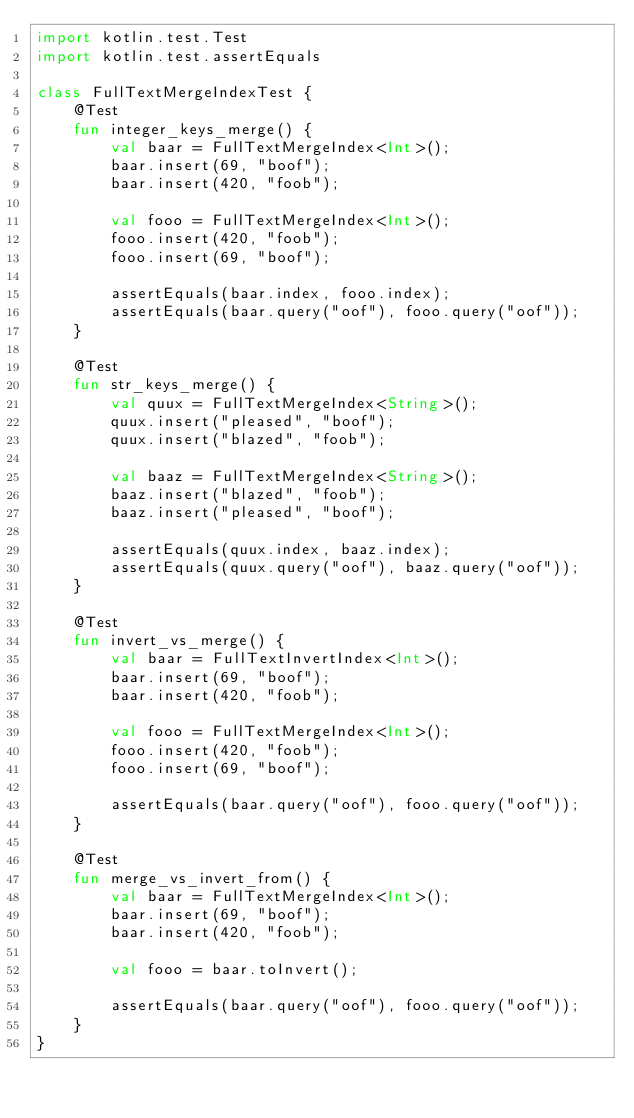Convert code to text. <code><loc_0><loc_0><loc_500><loc_500><_Kotlin_>import kotlin.test.Test
import kotlin.test.assertEquals

class FullTextMergeIndexTest {
    @Test
    fun integer_keys_merge() {
        val baar = FullTextMergeIndex<Int>();
        baar.insert(69, "boof");
        baar.insert(420, "foob");

        val fooo = FullTextMergeIndex<Int>();
        fooo.insert(420, "foob");
        fooo.insert(69, "boof");

        assertEquals(baar.index, fooo.index);
        assertEquals(baar.query("oof"), fooo.query("oof"));
    }

    @Test
    fun str_keys_merge() {
        val quux = FullTextMergeIndex<String>();
        quux.insert("pleased", "boof");
        quux.insert("blazed", "foob");

        val baaz = FullTextMergeIndex<String>();
        baaz.insert("blazed", "foob");
        baaz.insert("pleased", "boof");

        assertEquals(quux.index, baaz.index);
        assertEquals(quux.query("oof"), baaz.query("oof"));
    }

    @Test
    fun invert_vs_merge() {
        val baar = FullTextInvertIndex<Int>();
        baar.insert(69, "boof");
        baar.insert(420, "foob");

        val fooo = FullTextMergeIndex<Int>();
        fooo.insert(420, "foob");
        fooo.insert(69, "boof");

        assertEquals(baar.query("oof"), fooo.query("oof"));
    }

    @Test
    fun merge_vs_invert_from() {
        val baar = FullTextMergeIndex<Int>();
        baar.insert(69, "boof");
        baar.insert(420, "foob");

        val fooo = baar.toInvert();

        assertEquals(baar.query("oof"), fooo.query("oof"));
    }
}</code> 